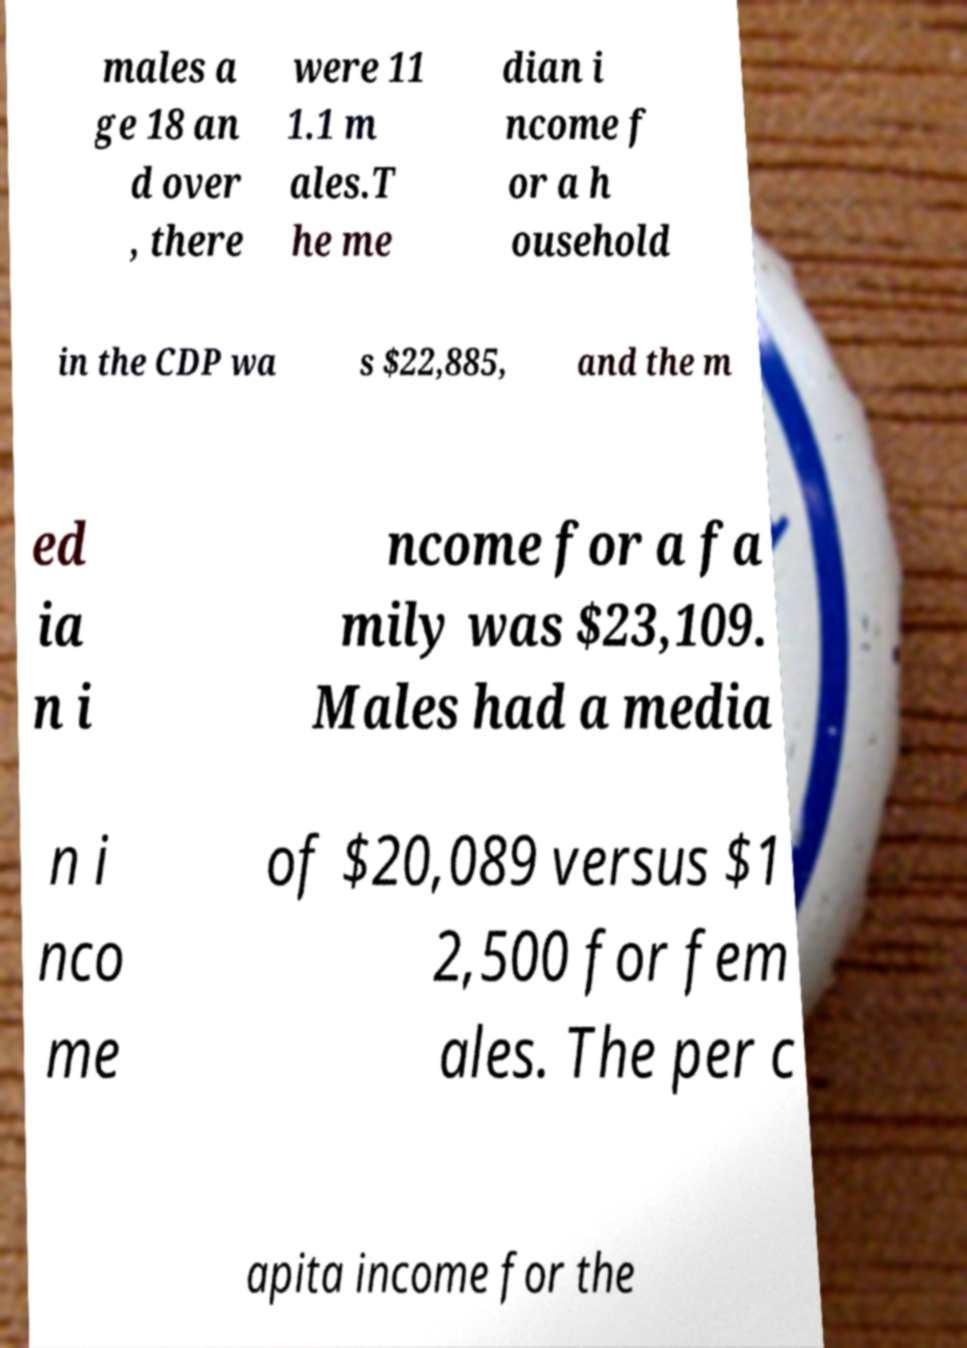Can you read and provide the text displayed in the image?This photo seems to have some interesting text. Can you extract and type it out for me? males a ge 18 an d over , there were 11 1.1 m ales.T he me dian i ncome f or a h ousehold in the CDP wa s $22,885, and the m ed ia n i ncome for a fa mily was $23,109. Males had a media n i nco me of $20,089 versus $1 2,500 for fem ales. The per c apita income for the 